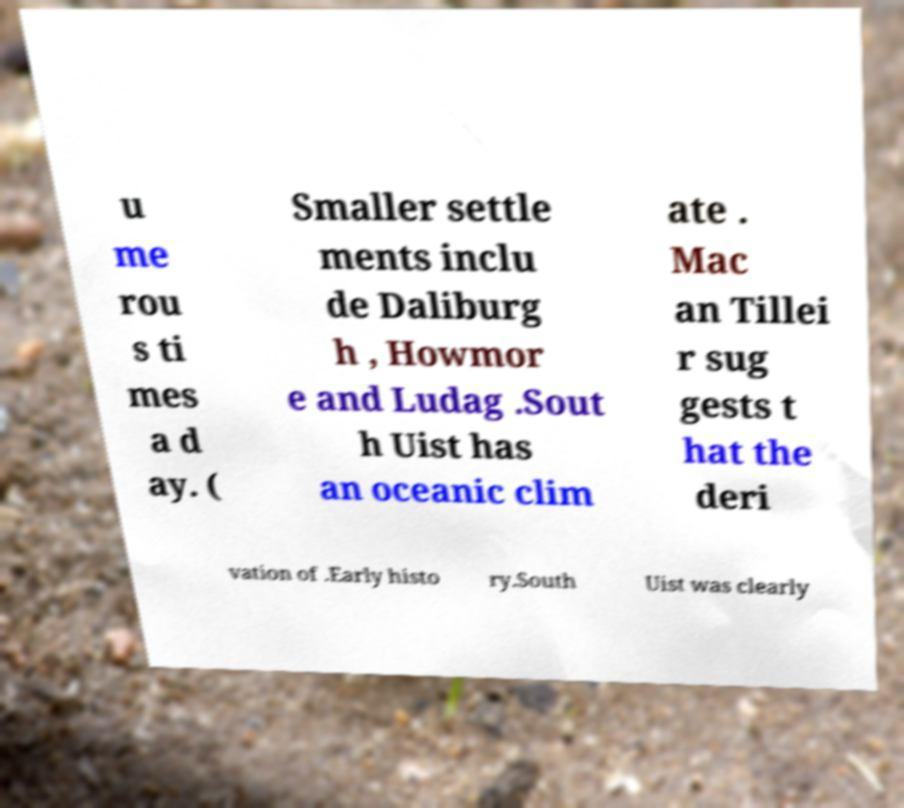For documentation purposes, I need the text within this image transcribed. Could you provide that? u me rou s ti mes a d ay. ( Smaller settle ments inclu de Daliburg h , Howmor e and Ludag .Sout h Uist has an oceanic clim ate . Mac an Tillei r sug gests t hat the deri vation of .Early histo ry.South Uist was clearly 